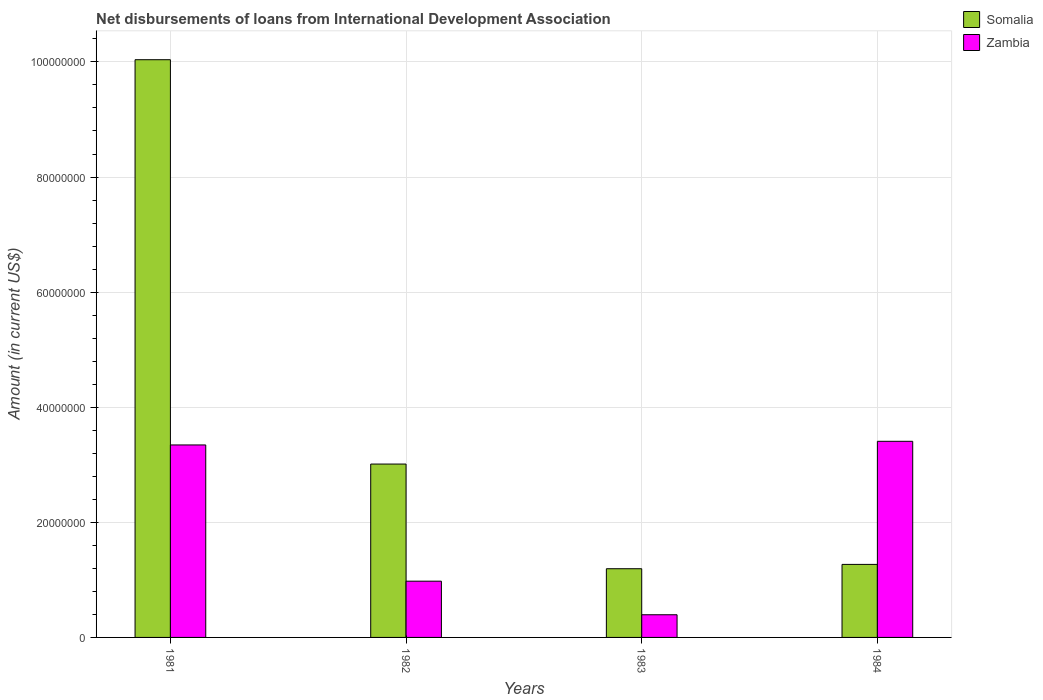How many different coloured bars are there?
Offer a very short reply. 2. In how many cases, is the number of bars for a given year not equal to the number of legend labels?
Ensure brevity in your answer.  0. What is the amount of loans disbursed in Zambia in 1984?
Keep it short and to the point. 3.41e+07. Across all years, what is the maximum amount of loans disbursed in Zambia?
Give a very brief answer. 3.41e+07. Across all years, what is the minimum amount of loans disbursed in Somalia?
Your answer should be compact. 1.19e+07. In which year was the amount of loans disbursed in Somalia maximum?
Make the answer very short. 1981. What is the total amount of loans disbursed in Somalia in the graph?
Your answer should be very brief. 1.55e+08. What is the difference between the amount of loans disbursed in Somalia in 1981 and that in 1984?
Offer a very short reply. 8.77e+07. What is the difference between the amount of loans disbursed in Somalia in 1982 and the amount of loans disbursed in Zambia in 1983?
Provide a succinct answer. 2.62e+07. What is the average amount of loans disbursed in Zambia per year?
Your answer should be very brief. 2.03e+07. In the year 1982, what is the difference between the amount of loans disbursed in Somalia and amount of loans disbursed in Zambia?
Your answer should be very brief. 2.04e+07. In how many years, is the amount of loans disbursed in Zambia greater than 60000000 US$?
Offer a terse response. 0. What is the ratio of the amount of loans disbursed in Somalia in 1982 to that in 1983?
Provide a short and direct response. 2.52. Is the amount of loans disbursed in Zambia in 1983 less than that in 1984?
Give a very brief answer. Yes. What is the difference between the highest and the second highest amount of loans disbursed in Zambia?
Ensure brevity in your answer.  6.34e+05. What is the difference between the highest and the lowest amount of loans disbursed in Zambia?
Make the answer very short. 3.01e+07. What does the 1st bar from the left in 1983 represents?
Make the answer very short. Somalia. What does the 1st bar from the right in 1981 represents?
Ensure brevity in your answer.  Zambia. How many bars are there?
Provide a succinct answer. 8. How many years are there in the graph?
Make the answer very short. 4. What is the difference between two consecutive major ticks on the Y-axis?
Your answer should be very brief. 2.00e+07. How many legend labels are there?
Provide a succinct answer. 2. What is the title of the graph?
Keep it short and to the point. Net disbursements of loans from International Development Association. Does "Colombia" appear as one of the legend labels in the graph?
Provide a short and direct response. No. What is the Amount (in current US$) in Somalia in 1981?
Provide a short and direct response. 1.00e+08. What is the Amount (in current US$) of Zambia in 1981?
Keep it short and to the point. 3.34e+07. What is the Amount (in current US$) in Somalia in 1982?
Offer a terse response. 3.01e+07. What is the Amount (in current US$) in Zambia in 1982?
Give a very brief answer. 9.77e+06. What is the Amount (in current US$) of Somalia in 1983?
Offer a very short reply. 1.19e+07. What is the Amount (in current US$) in Zambia in 1983?
Your answer should be compact. 3.94e+06. What is the Amount (in current US$) of Somalia in 1984?
Provide a succinct answer. 1.27e+07. What is the Amount (in current US$) in Zambia in 1984?
Provide a succinct answer. 3.41e+07. Across all years, what is the maximum Amount (in current US$) of Somalia?
Keep it short and to the point. 1.00e+08. Across all years, what is the maximum Amount (in current US$) in Zambia?
Offer a terse response. 3.41e+07. Across all years, what is the minimum Amount (in current US$) in Somalia?
Offer a terse response. 1.19e+07. Across all years, what is the minimum Amount (in current US$) of Zambia?
Your answer should be very brief. 3.94e+06. What is the total Amount (in current US$) of Somalia in the graph?
Keep it short and to the point. 1.55e+08. What is the total Amount (in current US$) of Zambia in the graph?
Provide a short and direct response. 8.12e+07. What is the difference between the Amount (in current US$) in Somalia in 1981 and that in 1982?
Your response must be concise. 7.03e+07. What is the difference between the Amount (in current US$) of Zambia in 1981 and that in 1982?
Ensure brevity in your answer.  2.37e+07. What is the difference between the Amount (in current US$) in Somalia in 1981 and that in 1983?
Keep it short and to the point. 8.84e+07. What is the difference between the Amount (in current US$) in Zambia in 1981 and that in 1983?
Your answer should be compact. 2.95e+07. What is the difference between the Amount (in current US$) in Somalia in 1981 and that in 1984?
Ensure brevity in your answer.  8.77e+07. What is the difference between the Amount (in current US$) of Zambia in 1981 and that in 1984?
Your response must be concise. -6.34e+05. What is the difference between the Amount (in current US$) of Somalia in 1982 and that in 1983?
Make the answer very short. 1.82e+07. What is the difference between the Amount (in current US$) of Zambia in 1982 and that in 1983?
Give a very brief answer. 5.83e+06. What is the difference between the Amount (in current US$) of Somalia in 1982 and that in 1984?
Give a very brief answer. 1.74e+07. What is the difference between the Amount (in current US$) in Zambia in 1982 and that in 1984?
Offer a terse response. -2.43e+07. What is the difference between the Amount (in current US$) of Somalia in 1983 and that in 1984?
Keep it short and to the point. -7.51e+05. What is the difference between the Amount (in current US$) in Zambia in 1983 and that in 1984?
Your answer should be very brief. -3.01e+07. What is the difference between the Amount (in current US$) in Somalia in 1981 and the Amount (in current US$) in Zambia in 1982?
Give a very brief answer. 9.06e+07. What is the difference between the Amount (in current US$) in Somalia in 1981 and the Amount (in current US$) in Zambia in 1983?
Give a very brief answer. 9.64e+07. What is the difference between the Amount (in current US$) in Somalia in 1981 and the Amount (in current US$) in Zambia in 1984?
Provide a short and direct response. 6.63e+07. What is the difference between the Amount (in current US$) in Somalia in 1982 and the Amount (in current US$) in Zambia in 1983?
Keep it short and to the point. 2.62e+07. What is the difference between the Amount (in current US$) of Somalia in 1982 and the Amount (in current US$) of Zambia in 1984?
Ensure brevity in your answer.  -3.95e+06. What is the difference between the Amount (in current US$) in Somalia in 1983 and the Amount (in current US$) in Zambia in 1984?
Your answer should be very brief. -2.21e+07. What is the average Amount (in current US$) in Somalia per year?
Ensure brevity in your answer.  3.88e+07. What is the average Amount (in current US$) in Zambia per year?
Your answer should be very brief. 2.03e+07. In the year 1981, what is the difference between the Amount (in current US$) in Somalia and Amount (in current US$) in Zambia?
Ensure brevity in your answer.  6.69e+07. In the year 1982, what is the difference between the Amount (in current US$) in Somalia and Amount (in current US$) in Zambia?
Make the answer very short. 2.04e+07. In the year 1983, what is the difference between the Amount (in current US$) of Somalia and Amount (in current US$) of Zambia?
Give a very brief answer. 8.00e+06. In the year 1984, what is the difference between the Amount (in current US$) in Somalia and Amount (in current US$) in Zambia?
Your answer should be very brief. -2.14e+07. What is the ratio of the Amount (in current US$) of Somalia in 1981 to that in 1982?
Ensure brevity in your answer.  3.33. What is the ratio of the Amount (in current US$) of Zambia in 1981 to that in 1982?
Offer a very short reply. 3.42. What is the ratio of the Amount (in current US$) in Somalia in 1981 to that in 1983?
Ensure brevity in your answer.  8.41. What is the ratio of the Amount (in current US$) of Zambia in 1981 to that in 1983?
Ensure brevity in your answer.  8.49. What is the ratio of the Amount (in current US$) in Somalia in 1981 to that in 1984?
Give a very brief answer. 7.91. What is the ratio of the Amount (in current US$) of Zambia in 1981 to that in 1984?
Give a very brief answer. 0.98. What is the ratio of the Amount (in current US$) in Somalia in 1982 to that in 1983?
Your answer should be very brief. 2.52. What is the ratio of the Amount (in current US$) in Zambia in 1982 to that in 1983?
Offer a very short reply. 2.48. What is the ratio of the Amount (in current US$) of Somalia in 1982 to that in 1984?
Provide a succinct answer. 2.37. What is the ratio of the Amount (in current US$) of Zambia in 1982 to that in 1984?
Make the answer very short. 0.29. What is the ratio of the Amount (in current US$) in Somalia in 1983 to that in 1984?
Offer a terse response. 0.94. What is the ratio of the Amount (in current US$) in Zambia in 1983 to that in 1984?
Provide a succinct answer. 0.12. What is the difference between the highest and the second highest Amount (in current US$) of Somalia?
Keep it short and to the point. 7.03e+07. What is the difference between the highest and the second highest Amount (in current US$) of Zambia?
Keep it short and to the point. 6.34e+05. What is the difference between the highest and the lowest Amount (in current US$) in Somalia?
Give a very brief answer. 8.84e+07. What is the difference between the highest and the lowest Amount (in current US$) in Zambia?
Ensure brevity in your answer.  3.01e+07. 